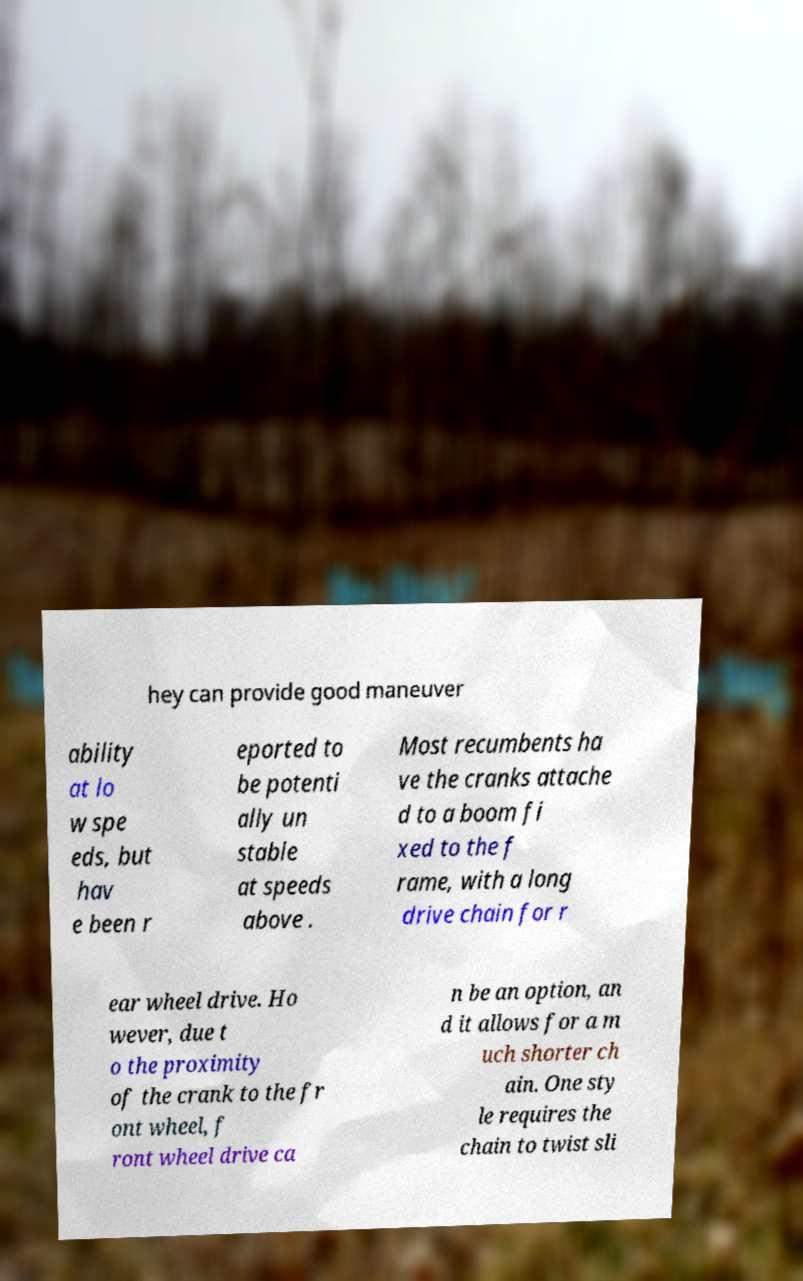Could you assist in decoding the text presented in this image and type it out clearly? hey can provide good maneuver ability at lo w spe eds, but hav e been r eported to be potenti ally un stable at speeds above . Most recumbents ha ve the cranks attache d to a boom fi xed to the f rame, with a long drive chain for r ear wheel drive. Ho wever, due t o the proximity of the crank to the fr ont wheel, f ront wheel drive ca n be an option, an d it allows for a m uch shorter ch ain. One sty le requires the chain to twist sli 